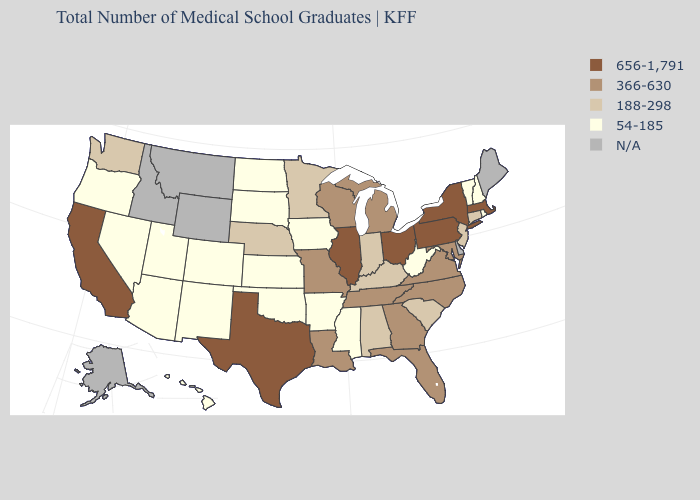What is the lowest value in the MidWest?
Answer briefly. 54-185. Name the states that have a value in the range 54-185?
Give a very brief answer. Arizona, Arkansas, Colorado, Hawaii, Iowa, Kansas, Mississippi, Nevada, New Hampshire, New Mexico, North Dakota, Oklahoma, Oregon, Rhode Island, South Dakota, Utah, Vermont, West Virginia. Which states hav the highest value in the South?
Short answer required. Texas. Name the states that have a value in the range 188-298?
Short answer required. Alabama, Connecticut, Indiana, Kentucky, Minnesota, Nebraska, New Jersey, South Carolina, Washington. Among the states that border Nevada , which have the lowest value?
Keep it brief. Arizona, Oregon, Utah. Among the states that border New York , which have the highest value?
Give a very brief answer. Massachusetts, Pennsylvania. What is the value of Utah?
Keep it brief. 54-185. What is the lowest value in states that border Idaho?
Write a very short answer. 54-185. What is the value of Hawaii?
Answer briefly. 54-185. Name the states that have a value in the range N/A?
Answer briefly. Alaska, Delaware, Idaho, Maine, Montana, Wyoming. Among the states that border Illinois , which have the lowest value?
Short answer required. Iowa. What is the lowest value in states that border Oregon?
Keep it brief. 54-185. Which states have the lowest value in the West?
Be succinct. Arizona, Colorado, Hawaii, Nevada, New Mexico, Oregon, Utah. Name the states that have a value in the range 366-630?
Keep it brief. Florida, Georgia, Louisiana, Maryland, Michigan, Missouri, North Carolina, Tennessee, Virginia, Wisconsin. What is the highest value in the USA?
Keep it brief. 656-1,791. 